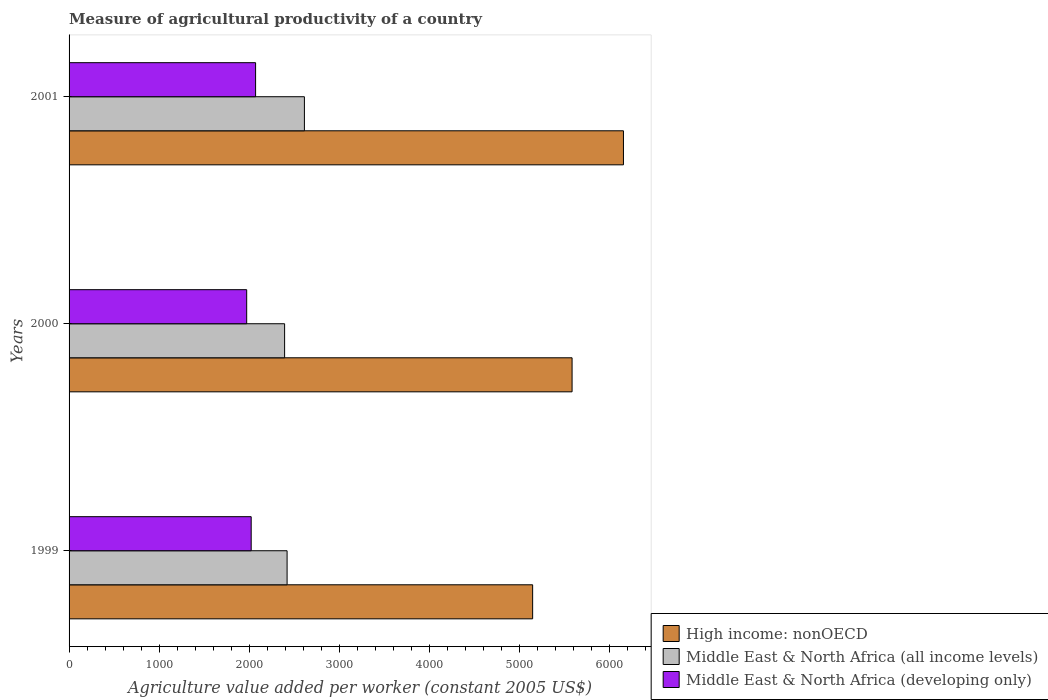How many groups of bars are there?
Give a very brief answer. 3. Are the number of bars per tick equal to the number of legend labels?
Your answer should be compact. Yes. Are the number of bars on each tick of the Y-axis equal?
Offer a terse response. Yes. What is the measure of agricultural productivity in Middle East & North Africa (developing only) in 2001?
Keep it short and to the point. 2071.08. Across all years, what is the maximum measure of agricultural productivity in High income: nonOECD?
Provide a short and direct response. 6155.66. Across all years, what is the minimum measure of agricultural productivity in Middle East & North Africa (developing only)?
Give a very brief answer. 1972.26. In which year was the measure of agricultural productivity in Middle East & North Africa (developing only) maximum?
Ensure brevity in your answer.  2001. In which year was the measure of agricultural productivity in Middle East & North Africa (developing only) minimum?
Ensure brevity in your answer.  2000. What is the total measure of agricultural productivity in Middle East & North Africa (all income levels) in the graph?
Your answer should be very brief. 7427.3. What is the difference between the measure of agricultural productivity in Middle East & North Africa (all income levels) in 1999 and that in 2001?
Offer a very short reply. -192.3. What is the difference between the measure of agricultural productivity in Middle East & North Africa (all income levels) in 2000 and the measure of agricultural productivity in High income: nonOECD in 2001?
Offer a very short reply. -3762.3. What is the average measure of agricultural productivity in High income: nonOECD per year?
Ensure brevity in your answer.  5629.47. In the year 2000, what is the difference between the measure of agricultural productivity in Middle East & North Africa (developing only) and measure of agricultural productivity in High income: nonOECD?
Provide a short and direct response. -3613.07. What is the ratio of the measure of agricultural productivity in Middle East & North Africa (developing only) in 1999 to that in 2001?
Your answer should be very brief. 0.98. Is the measure of agricultural productivity in Middle East & North Africa (all income levels) in 1999 less than that in 2000?
Provide a short and direct response. No. Is the difference between the measure of agricultural productivity in Middle East & North Africa (developing only) in 2000 and 2001 greater than the difference between the measure of agricultural productivity in High income: nonOECD in 2000 and 2001?
Your answer should be very brief. Yes. What is the difference between the highest and the second highest measure of agricultural productivity in Middle East & North Africa (developing only)?
Your answer should be very brief. 48.96. What is the difference between the highest and the lowest measure of agricultural productivity in High income: nonOECD?
Ensure brevity in your answer.  1008.22. Is the sum of the measure of agricultural productivity in High income: nonOECD in 2000 and 2001 greater than the maximum measure of agricultural productivity in Middle East & North Africa (developing only) across all years?
Offer a very short reply. Yes. What does the 1st bar from the top in 1999 represents?
Give a very brief answer. Middle East & North Africa (developing only). What does the 3rd bar from the bottom in 1999 represents?
Give a very brief answer. Middle East & North Africa (developing only). How many bars are there?
Your response must be concise. 9. Are all the bars in the graph horizontal?
Your response must be concise. Yes. How many years are there in the graph?
Your answer should be compact. 3. Does the graph contain any zero values?
Your response must be concise. No. Does the graph contain grids?
Ensure brevity in your answer.  No. How many legend labels are there?
Offer a terse response. 3. What is the title of the graph?
Offer a terse response. Measure of agricultural productivity of a country. Does "Tonga" appear as one of the legend labels in the graph?
Your answer should be very brief. No. What is the label or title of the X-axis?
Ensure brevity in your answer.  Agriculture value added per worker (constant 2005 US$). What is the Agriculture value added per worker (constant 2005 US$) of High income: nonOECD in 1999?
Give a very brief answer. 5147.44. What is the Agriculture value added per worker (constant 2005 US$) in Middle East & North Africa (all income levels) in 1999?
Provide a short and direct response. 2420.82. What is the Agriculture value added per worker (constant 2005 US$) in Middle East & North Africa (developing only) in 1999?
Provide a short and direct response. 2022.12. What is the Agriculture value added per worker (constant 2005 US$) in High income: nonOECD in 2000?
Provide a short and direct response. 5585.32. What is the Agriculture value added per worker (constant 2005 US$) of Middle East & North Africa (all income levels) in 2000?
Offer a terse response. 2393.36. What is the Agriculture value added per worker (constant 2005 US$) of Middle East & North Africa (developing only) in 2000?
Keep it short and to the point. 1972.26. What is the Agriculture value added per worker (constant 2005 US$) of High income: nonOECD in 2001?
Your answer should be very brief. 6155.66. What is the Agriculture value added per worker (constant 2005 US$) of Middle East & North Africa (all income levels) in 2001?
Offer a very short reply. 2613.12. What is the Agriculture value added per worker (constant 2005 US$) in Middle East & North Africa (developing only) in 2001?
Your response must be concise. 2071.08. Across all years, what is the maximum Agriculture value added per worker (constant 2005 US$) in High income: nonOECD?
Offer a very short reply. 6155.66. Across all years, what is the maximum Agriculture value added per worker (constant 2005 US$) in Middle East & North Africa (all income levels)?
Offer a very short reply. 2613.12. Across all years, what is the maximum Agriculture value added per worker (constant 2005 US$) in Middle East & North Africa (developing only)?
Provide a short and direct response. 2071.08. Across all years, what is the minimum Agriculture value added per worker (constant 2005 US$) in High income: nonOECD?
Your answer should be very brief. 5147.44. Across all years, what is the minimum Agriculture value added per worker (constant 2005 US$) of Middle East & North Africa (all income levels)?
Your answer should be compact. 2393.36. Across all years, what is the minimum Agriculture value added per worker (constant 2005 US$) of Middle East & North Africa (developing only)?
Make the answer very short. 1972.26. What is the total Agriculture value added per worker (constant 2005 US$) of High income: nonOECD in the graph?
Your answer should be compact. 1.69e+04. What is the total Agriculture value added per worker (constant 2005 US$) of Middle East & North Africa (all income levels) in the graph?
Offer a terse response. 7427.3. What is the total Agriculture value added per worker (constant 2005 US$) of Middle East & North Africa (developing only) in the graph?
Your answer should be very brief. 6065.45. What is the difference between the Agriculture value added per worker (constant 2005 US$) of High income: nonOECD in 1999 and that in 2000?
Your response must be concise. -437.89. What is the difference between the Agriculture value added per worker (constant 2005 US$) in Middle East & North Africa (all income levels) in 1999 and that in 2000?
Your answer should be very brief. 27.47. What is the difference between the Agriculture value added per worker (constant 2005 US$) of Middle East & North Africa (developing only) in 1999 and that in 2000?
Offer a very short reply. 49.86. What is the difference between the Agriculture value added per worker (constant 2005 US$) in High income: nonOECD in 1999 and that in 2001?
Offer a very short reply. -1008.22. What is the difference between the Agriculture value added per worker (constant 2005 US$) of Middle East & North Africa (all income levels) in 1999 and that in 2001?
Offer a terse response. -192.3. What is the difference between the Agriculture value added per worker (constant 2005 US$) in Middle East & North Africa (developing only) in 1999 and that in 2001?
Your answer should be compact. -48.96. What is the difference between the Agriculture value added per worker (constant 2005 US$) in High income: nonOECD in 2000 and that in 2001?
Provide a short and direct response. -570.33. What is the difference between the Agriculture value added per worker (constant 2005 US$) of Middle East & North Africa (all income levels) in 2000 and that in 2001?
Your answer should be very brief. -219.77. What is the difference between the Agriculture value added per worker (constant 2005 US$) of Middle East & North Africa (developing only) in 2000 and that in 2001?
Give a very brief answer. -98.82. What is the difference between the Agriculture value added per worker (constant 2005 US$) of High income: nonOECD in 1999 and the Agriculture value added per worker (constant 2005 US$) of Middle East & North Africa (all income levels) in 2000?
Your response must be concise. 2754.08. What is the difference between the Agriculture value added per worker (constant 2005 US$) in High income: nonOECD in 1999 and the Agriculture value added per worker (constant 2005 US$) in Middle East & North Africa (developing only) in 2000?
Make the answer very short. 3175.18. What is the difference between the Agriculture value added per worker (constant 2005 US$) in Middle East & North Africa (all income levels) in 1999 and the Agriculture value added per worker (constant 2005 US$) in Middle East & North Africa (developing only) in 2000?
Keep it short and to the point. 448.57. What is the difference between the Agriculture value added per worker (constant 2005 US$) of High income: nonOECD in 1999 and the Agriculture value added per worker (constant 2005 US$) of Middle East & North Africa (all income levels) in 2001?
Offer a very short reply. 2534.31. What is the difference between the Agriculture value added per worker (constant 2005 US$) of High income: nonOECD in 1999 and the Agriculture value added per worker (constant 2005 US$) of Middle East & North Africa (developing only) in 2001?
Keep it short and to the point. 3076.36. What is the difference between the Agriculture value added per worker (constant 2005 US$) of Middle East & North Africa (all income levels) in 1999 and the Agriculture value added per worker (constant 2005 US$) of Middle East & North Africa (developing only) in 2001?
Keep it short and to the point. 349.74. What is the difference between the Agriculture value added per worker (constant 2005 US$) in High income: nonOECD in 2000 and the Agriculture value added per worker (constant 2005 US$) in Middle East & North Africa (all income levels) in 2001?
Keep it short and to the point. 2972.2. What is the difference between the Agriculture value added per worker (constant 2005 US$) in High income: nonOECD in 2000 and the Agriculture value added per worker (constant 2005 US$) in Middle East & North Africa (developing only) in 2001?
Ensure brevity in your answer.  3514.25. What is the difference between the Agriculture value added per worker (constant 2005 US$) in Middle East & North Africa (all income levels) in 2000 and the Agriculture value added per worker (constant 2005 US$) in Middle East & North Africa (developing only) in 2001?
Your answer should be very brief. 322.28. What is the average Agriculture value added per worker (constant 2005 US$) in High income: nonOECD per year?
Provide a succinct answer. 5629.47. What is the average Agriculture value added per worker (constant 2005 US$) of Middle East & North Africa (all income levels) per year?
Keep it short and to the point. 2475.77. What is the average Agriculture value added per worker (constant 2005 US$) of Middle East & North Africa (developing only) per year?
Give a very brief answer. 2021.82. In the year 1999, what is the difference between the Agriculture value added per worker (constant 2005 US$) of High income: nonOECD and Agriculture value added per worker (constant 2005 US$) of Middle East & North Africa (all income levels)?
Make the answer very short. 2726.62. In the year 1999, what is the difference between the Agriculture value added per worker (constant 2005 US$) of High income: nonOECD and Agriculture value added per worker (constant 2005 US$) of Middle East & North Africa (developing only)?
Give a very brief answer. 3125.32. In the year 1999, what is the difference between the Agriculture value added per worker (constant 2005 US$) in Middle East & North Africa (all income levels) and Agriculture value added per worker (constant 2005 US$) in Middle East & North Africa (developing only)?
Offer a very short reply. 398.7. In the year 2000, what is the difference between the Agriculture value added per worker (constant 2005 US$) of High income: nonOECD and Agriculture value added per worker (constant 2005 US$) of Middle East & North Africa (all income levels)?
Provide a short and direct response. 3191.97. In the year 2000, what is the difference between the Agriculture value added per worker (constant 2005 US$) in High income: nonOECD and Agriculture value added per worker (constant 2005 US$) in Middle East & North Africa (developing only)?
Make the answer very short. 3613.07. In the year 2000, what is the difference between the Agriculture value added per worker (constant 2005 US$) of Middle East & North Africa (all income levels) and Agriculture value added per worker (constant 2005 US$) of Middle East & North Africa (developing only)?
Offer a very short reply. 421.1. In the year 2001, what is the difference between the Agriculture value added per worker (constant 2005 US$) of High income: nonOECD and Agriculture value added per worker (constant 2005 US$) of Middle East & North Africa (all income levels)?
Make the answer very short. 3542.53. In the year 2001, what is the difference between the Agriculture value added per worker (constant 2005 US$) of High income: nonOECD and Agriculture value added per worker (constant 2005 US$) of Middle East & North Africa (developing only)?
Keep it short and to the point. 4084.58. In the year 2001, what is the difference between the Agriculture value added per worker (constant 2005 US$) of Middle East & North Africa (all income levels) and Agriculture value added per worker (constant 2005 US$) of Middle East & North Africa (developing only)?
Make the answer very short. 542.05. What is the ratio of the Agriculture value added per worker (constant 2005 US$) of High income: nonOECD in 1999 to that in 2000?
Your answer should be very brief. 0.92. What is the ratio of the Agriculture value added per worker (constant 2005 US$) of Middle East & North Africa (all income levels) in 1999 to that in 2000?
Ensure brevity in your answer.  1.01. What is the ratio of the Agriculture value added per worker (constant 2005 US$) in Middle East & North Africa (developing only) in 1999 to that in 2000?
Your answer should be compact. 1.03. What is the ratio of the Agriculture value added per worker (constant 2005 US$) in High income: nonOECD in 1999 to that in 2001?
Offer a terse response. 0.84. What is the ratio of the Agriculture value added per worker (constant 2005 US$) of Middle East & North Africa (all income levels) in 1999 to that in 2001?
Provide a succinct answer. 0.93. What is the ratio of the Agriculture value added per worker (constant 2005 US$) of Middle East & North Africa (developing only) in 1999 to that in 2001?
Your answer should be compact. 0.98. What is the ratio of the Agriculture value added per worker (constant 2005 US$) of High income: nonOECD in 2000 to that in 2001?
Your answer should be very brief. 0.91. What is the ratio of the Agriculture value added per worker (constant 2005 US$) in Middle East & North Africa (all income levels) in 2000 to that in 2001?
Offer a terse response. 0.92. What is the ratio of the Agriculture value added per worker (constant 2005 US$) in Middle East & North Africa (developing only) in 2000 to that in 2001?
Make the answer very short. 0.95. What is the difference between the highest and the second highest Agriculture value added per worker (constant 2005 US$) in High income: nonOECD?
Ensure brevity in your answer.  570.33. What is the difference between the highest and the second highest Agriculture value added per worker (constant 2005 US$) in Middle East & North Africa (all income levels)?
Ensure brevity in your answer.  192.3. What is the difference between the highest and the second highest Agriculture value added per worker (constant 2005 US$) in Middle East & North Africa (developing only)?
Give a very brief answer. 48.96. What is the difference between the highest and the lowest Agriculture value added per worker (constant 2005 US$) in High income: nonOECD?
Keep it short and to the point. 1008.22. What is the difference between the highest and the lowest Agriculture value added per worker (constant 2005 US$) of Middle East & North Africa (all income levels)?
Give a very brief answer. 219.77. What is the difference between the highest and the lowest Agriculture value added per worker (constant 2005 US$) of Middle East & North Africa (developing only)?
Keep it short and to the point. 98.82. 